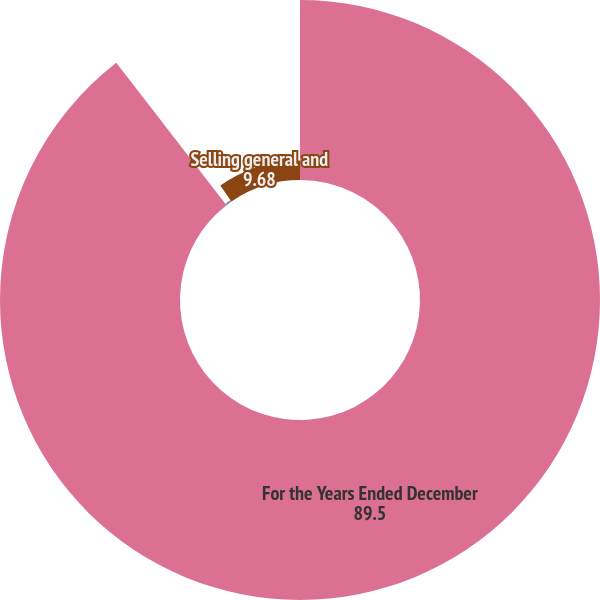Convert chart. <chart><loc_0><loc_0><loc_500><loc_500><pie_chart><fcel>For the Years Ended December<fcel>Cost of products sold<fcel>Selling general and<nl><fcel>89.5%<fcel>0.81%<fcel>9.68%<nl></chart> 